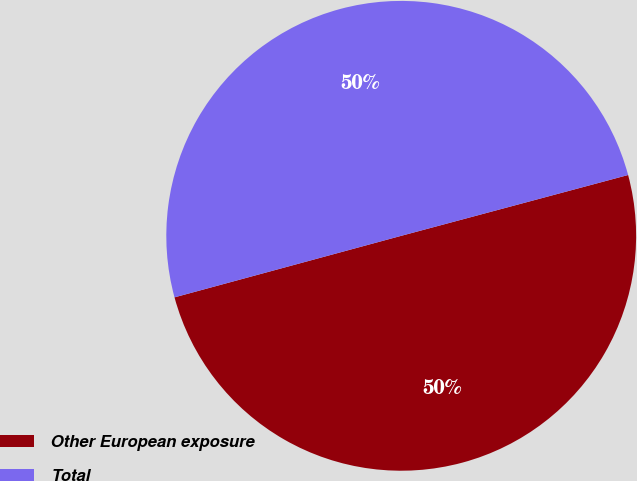Convert chart to OTSL. <chart><loc_0><loc_0><loc_500><loc_500><pie_chart><fcel>Other European exposure<fcel>Total<nl><fcel>49.95%<fcel>50.05%<nl></chart> 